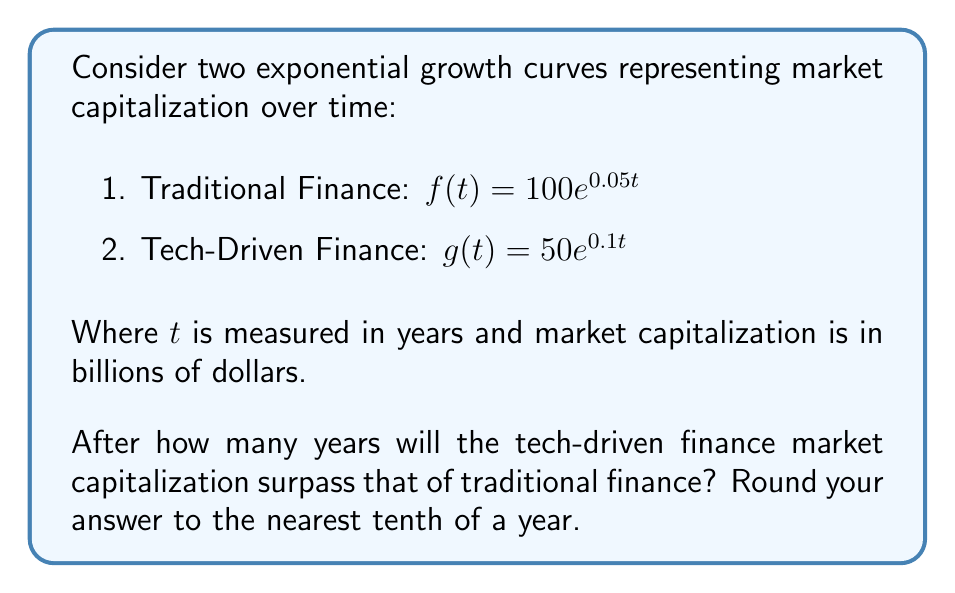Show me your answer to this math problem. To solve this problem, we need to find the point of intersection between the two curves. This occurs when $f(t) = g(t)$.

1) Set up the equation:
   $100e^{0.05t} = 50e^{0.1t}$

2) Divide both sides by 50:
   $2e^{0.05t} = e^{0.1t}$

3) Take the natural logarithm of both sides:
   $\ln(2e^{0.05t}) = \ln(e^{0.1t})$

4) Using logarithm properties:
   $\ln(2) + \ln(e^{0.05t}) = \ln(e^{0.1t})$
   $\ln(2) + 0.05t = 0.1t$

5) Subtract 0.05t from both sides:
   $\ln(2) = 0.05t$

6) Divide both sides by 0.05:
   $\frac{\ln(2)}{0.05} = t$

7) Calculate the result:
   $t = \frac{\ln(2)}{0.05} \approx 13.8629$

8) Rounding to the nearest tenth:
   $t \approx 13.9$ years

Therefore, it will take approximately 13.9 years for the tech-driven finance market capitalization to surpass that of traditional finance.
Answer: 13.9 years 